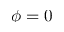Convert formula to latex. <formula><loc_0><loc_0><loc_500><loc_500>\phi = 0</formula> 